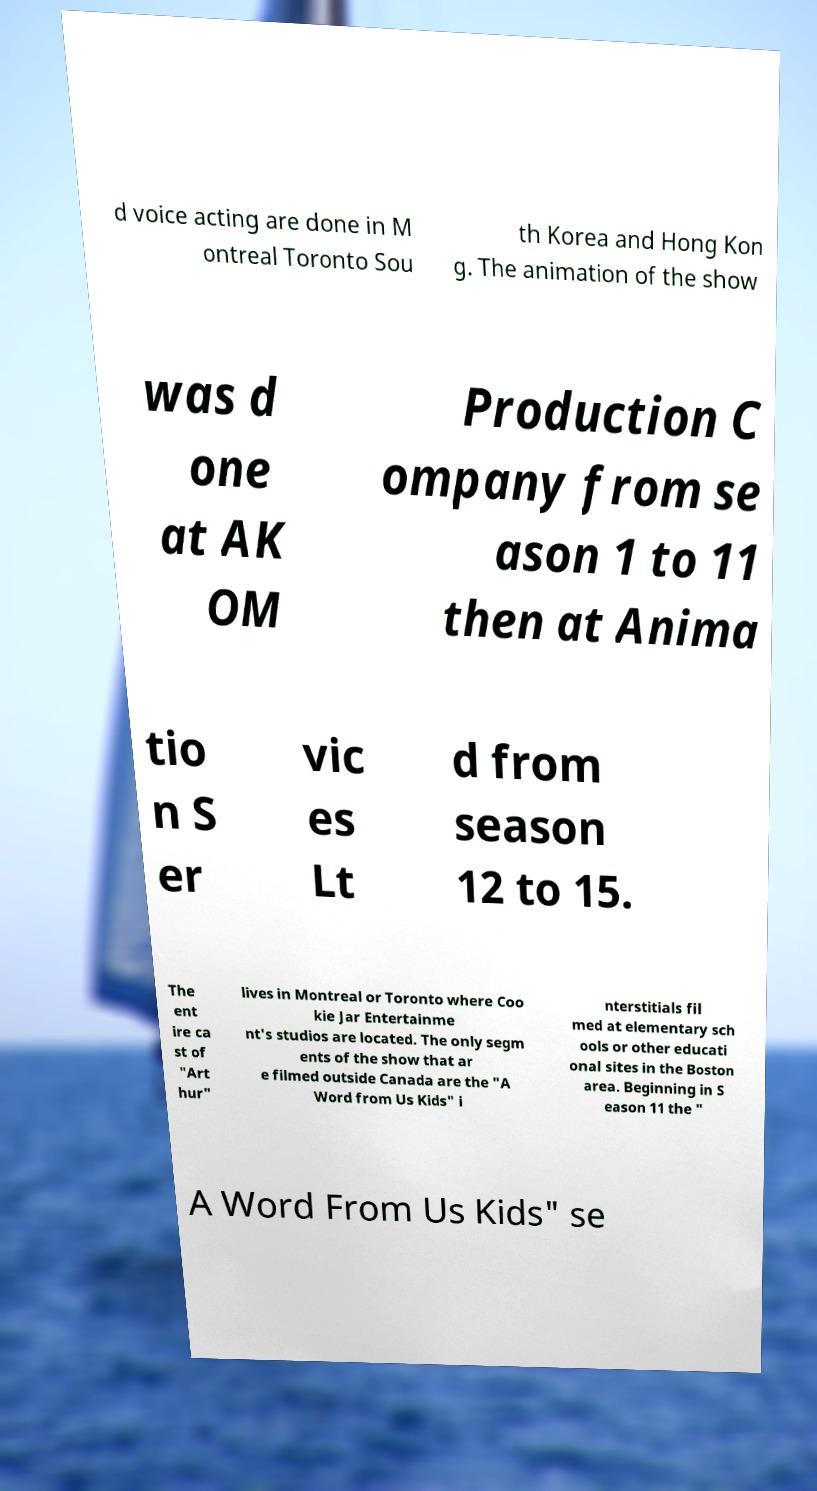Please identify and transcribe the text found in this image. d voice acting are done in M ontreal Toronto Sou th Korea and Hong Kon g. The animation of the show was d one at AK OM Production C ompany from se ason 1 to 11 then at Anima tio n S er vic es Lt d from season 12 to 15. The ent ire ca st of "Art hur" lives in Montreal or Toronto where Coo kie Jar Entertainme nt's studios are located. The only segm ents of the show that ar e filmed outside Canada are the "A Word from Us Kids" i nterstitials fil med at elementary sch ools or other educati onal sites in the Boston area. Beginning in S eason 11 the " A Word From Us Kids" se 